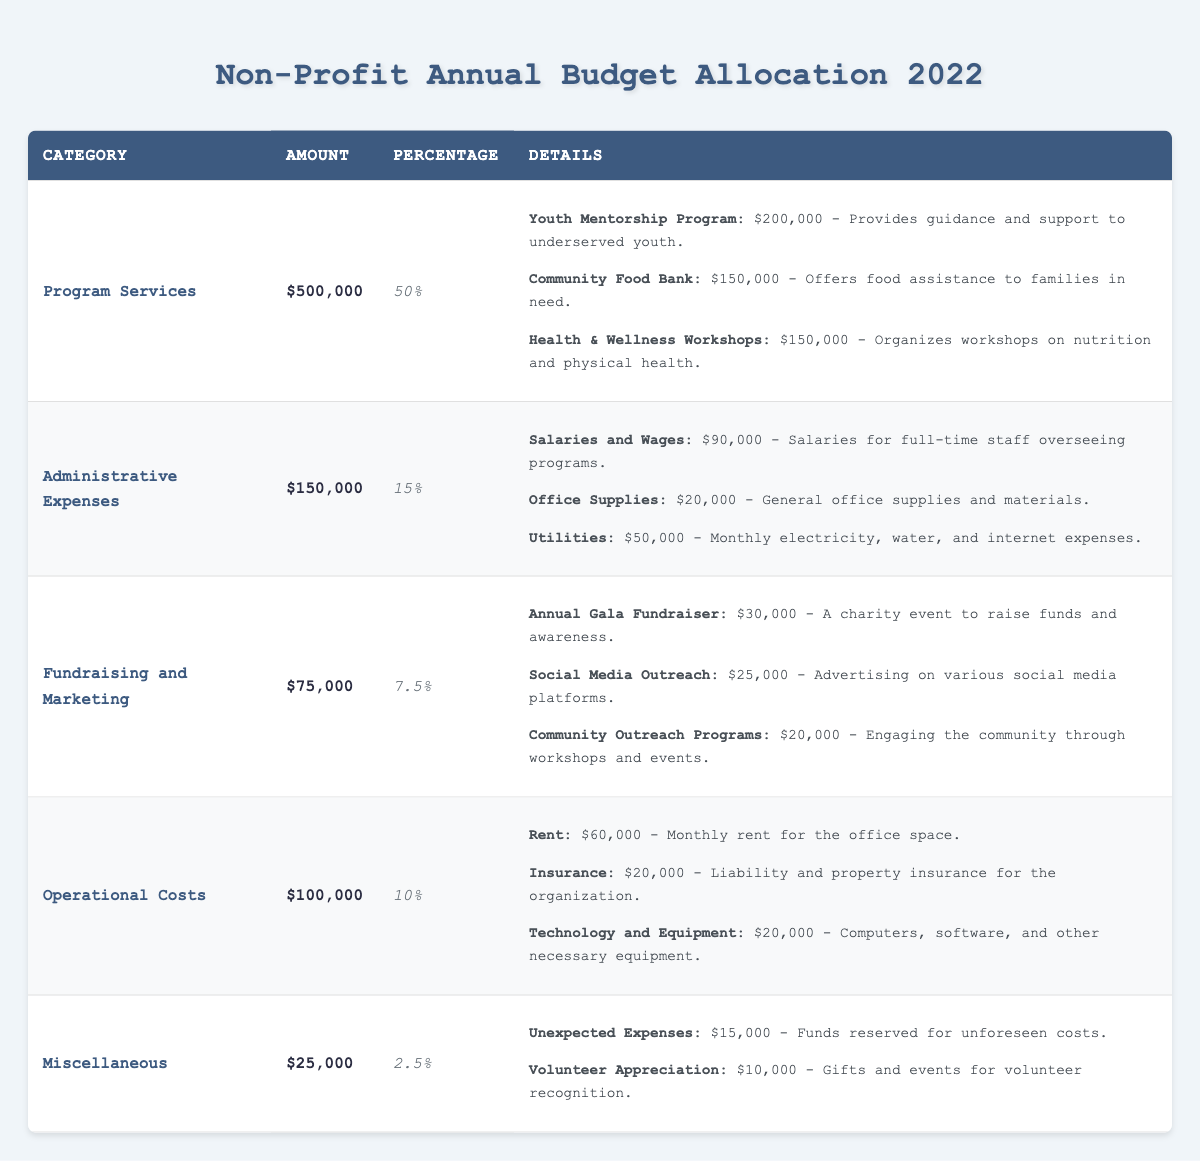What is the total budget allocation for the Program Services category? The amount allocated to Program Services is given directly in the table as $500,000.
Answer: $500,000 Which category has the highest budget allocation? By comparing the amounts in each category, Program Services has the highest allocation at $500,000.
Answer: Program Services What percentage of the total budget is allocated to Administrative Expenses? The percentage allocated to Administrative Expenses is given in the table as 15%.
Answer: 15% How much funding is dedicated to the Youth Mentorship Program? The funding for the Youth Mentorship Program is specified in the details under Program Services as $200,000.
Answer: $200,000 Is the amount allocated for Operational Costs greater than the amount for Fundraising and Marketing? Operational Costs is $100,000 and Fundraising and Marketing is $75,000. Since $100,000 is greater than $75,000, the statement is true.
Answer: Yes What is the total funding allocated to all programs under Program Services? Adding the funding amounts for the three programs: Youth Mentorship Program ($200,000) + Community Food Bank ($150,000) + Health & Wellness Workshops ($150,000) gives $200,000 + $150,000 + $150,000 = $500,000, which matches the total for Program Services.
Answer: $500,000 Calculate the total budget allocated for Administrative Expenses and Operational Costs combined. The total for Administrative Expenses is $150,000, and for Operational Costs it is $100,000. Adding them together: $150,000 + $100,000 = $250,000.
Answer: $250,000 What is the total amount reserved for Miscellaneous expenses? The Miscellaneous category has a total amount allocated of $25,000 as shown in the table.
Answer: $25,000 Is the total funding for the Annual Gala Fundraiser more than the combined funding for Social Media Outreach and Community Outreach Programs? The Annual Gala Fundraiser is allocated $30,000, while Social Media Outreach ($25,000) and Community Outreach Programs ($20,000) when added together equals $45,000. Since $30,000 is less than $45,000, the answer is no.
Answer: No What percentage of the total budget is the amount allocated for Fundraising and Marketing? The Fundraising and Marketing category is allocated $75,000 out of a total budget of $1,000,000 (sum of all categories). So the percentage is ($75,000 / $1,000,000) * 100 = 7.5%.
Answer: 7.5% What is the ratio of the budget for Program Services to the budget for Miscellaneous expenses? The budget for Program Services is $500,000 and for Miscellaneous is $25,000. The ratio is 500,000 : 25,000, which simplifies to 20 : 1.
Answer: 20:1 